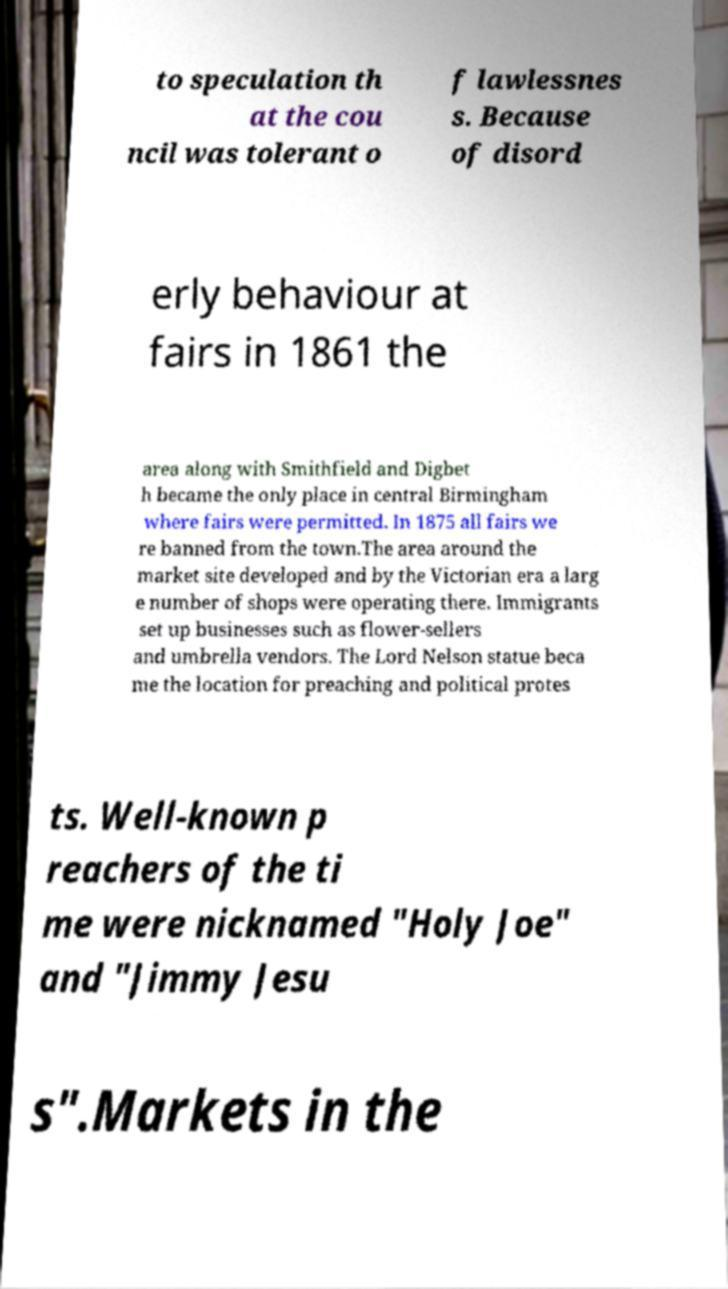I need the written content from this picture converted into text. Can you do that? to speculation th at the cou ncil was tolerant o f lawlessnes s. Because of disord erly behaviour at fairs in 1861 the area along with Smithfield and Digbet h became the only place in central Birmingham where fairs were permitted. In 1875 all fairs we re banned from the town.The area around the market site developed and by the Victorian era a larg e number of shops were operating there. Immigrants set up businesses such as flower-sellers and umbrella vendors. The Lord Nelson statue beca me the location for preaching and political protes ts. Well-known p reachers of the ti me were nicknamed "Holy Joe" and "Jimmy Jesu s".Markets in the 